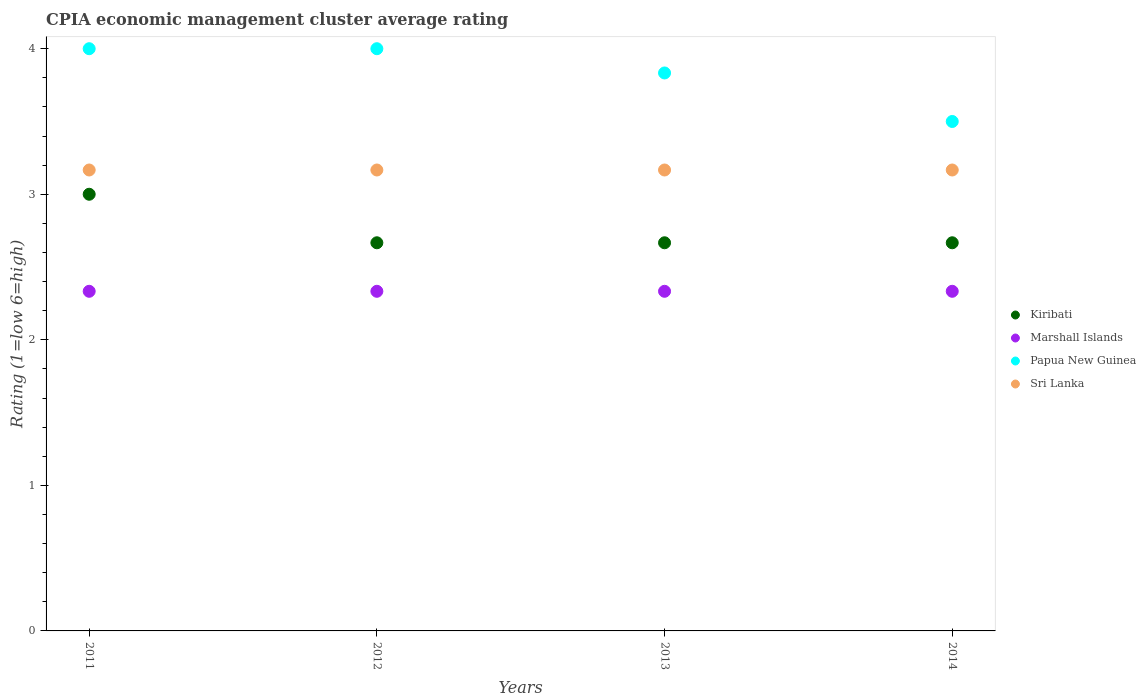Is the number of dotlines equal to the number of legend labels?
Provide a short and direct response. Yes. What is the CPIA rating in Marshall Islands in 2011?
Keep it short and to the point. 2.33. Across all years, what is the maximum CPIA rating in Marshall Islands?
Make the answer very short. 2.33. Across all years, what is the minimum CPIA rating in Kiribati?
Ensure brevity in your answer.  2.67. In which year was the CPIA rating in Papua New Guinea maximum?
Provide a succinct answer. 2011. What is the total CPIA rating in Marshall Islands in the graph?
Your response must be concise. 9.33. What is the difference between the CPIA rating in Kiribati in 2011 and that in 2014?
Ensure brevity in your answer.  0.33. What is the difference between the CPIA rating in Kiribati in 2011 and the CPIA rating in Marshall Islands in 2014?
Keep it short and to the point. 0.67. What is the average CPIA rating in Marshall Islands per year?
Ensure brevity in your answer.  2.33. In the year 2014, what is the difference between the CPIA rating in Papua New Guinea and CPIA rating in Marshall Islands?
Keep it short and to the point. 1.17. In how many years, is the CPIA rating in Sri Lanka greater than 1.8?
Your answer should be compact. 4. What is the ratio of the CPIA rating in Sri Lanka in 2011 to that in 2012?
Keep it short and to the point. 1. Is the CPIA rating in Sri Lanka in 2011 less than that in 2012?
Your answer should be compact. No. What is the difference between the highest and the second highest CPIA rating in Marshall Islands?
Your answer should be very brief. 0. What is the difference between the highest and the lowest CPIA rating in Kiribati?
Ensure brevity in your answer.  0.33. Is it the case that in every year, the sum of the CPIA rating in Sri Lanka and CPIA rating in Papua New Guinea  is greater than the sum of CPIA rating in Kiribati and CPIA rating in Marshall Islands?
Give a very brief answer. Yes. Does the CPIA rating in Sri Lanka monotonically increase over the years?
Ensure brevity in your answer.  No. How many years are there in the graph?
Your answer should be very brief. 4. What is the difference between two consecutive major ticks on the Y-axis?
Keep it short and to the point. 1. Does the graph contain grids?
Your answer should be compact. No. What is the title of the graph?
Provide a succinct answer. CPIA economic management cluster average rating. What is the label or title of the X-axis?
Your answer should be compact. Years. What is the label or title of the Y-axis?
Keep it short and to the point. Rating (1=low 6=high). What is the Rating (1=low 6=high) in Marshall Islands in 2011?
Keep it short and to the point. 2.33. What is the Rating (1=low 6=high) in Papua New Guinea in 2011?
Ensure brevity in your answer.  4. What is the Rating (1=low 6=high) of Sri Lanka in 2011?
Offer a terse response. 3.17. What is the Rating (1=low 6=high) in Kiribati in 2012?
Provide a short and direct response. 2.67. What is the Rating (1=low 6=high) in Marshall Islands in 2012?
Make the answer very short. 2.33. What is the Rating (1=low 6=high) of Sri Lanka in 2012?
Make the answer very short. 3.17. What is the Rating (1=low 6=high) in Kiribati in 2013?
Keep it short and to the point. 2.67. What is the Rating (1=low 6=high) in Marshall Islands in 2013?
Give a very brief answer. 2.33. What is the Rating (1=low 6=high) in Papua New Guinea in 2013?
Provide a succinct answer. 3.83. What is the Rating (1=low 6=high) of Sri Lanka in 2013?
Make the answer very short. 3.17. What is the Rating (1=low 6=high) of Kiribati in 2014?
Your response must be concise. 2.67. What is the Rating (1=low 6=high) in Marshall Islands in 2014?
Your answer should be compact. 2.33. What is the Rating (1=low 6=high) in Sri Lanka in 2014?
Make the answer very short. 3.17. Across all years, what is the maximum Rating (1=low 6=high) in Marshall Islands?
Your answer should be compact. 2.33. Across all years, what is the maximum Rating (1=low 6=high) of Papua New Guinea?
Make the answer very short. 4. Across all years, what is the maximum Rating (1=low 6=high) in Sri Lanka?
Offer a very short reply. 3.17. Across all years, what is the minimum Rating (1=low 6=high) of Kiribati?
Ensure brevity in your answer.  2.67. Across all years, what is the minimum Rating (1=low 6=high) of Marshall Islands?
Your answer should be compact. 2.33. Across all years, what is the minimum Rating (1=low 6=high) of Papua New Guinea?
Provide a short and direct response. 3.5. Across all years, what is the minimum Rating (1=low 6=high) in Sri Lanka?
Offer a very short reply. 3.17. What is the total Rating (1=low 6=high) of Kiribati in the graph?
Your answer should be compact. 11. What is the total Rating (1=low 6=high) of Marshall Islands in the graph?
Make the answer very short. 9.33. What is the total Rating (1=low 6=high) in Papua New Guinea in the graph?
Ensure brevity in your answer.  15.33. What is the total Rating (1=low 6=high) in Sri Lanka in the graph?
Make the answer very short. 12.67. What is the difference between the Rating (1=low 6=high) in Kiribati in 2011 and that in 2012?
Your response must be concise. 0.33. What is the difference between the Rating (1=low 6=high) of Marshall Islands in 2011 and that in 2012?
Offer a terse response. 0. What is the difference between the Rating (1=low 6=high) in Sri Lanka in 2011 and that in 2012?
Give a very brief answer. 0. What is the difference between the Rating (1=low 6=high) of Kiribati in 2011 and that in 2013?
Offer a very short reply. 0.33. What is the difference between the Rating (1=low 6=high) of Marshall Islands in 2011 and that in 2013?
Your answer should be compact. 0. What is the difference between the Rating (1=low 6=high) in Sri Lanka in 2011 and that in 2013?
Provide a short and direct response. 0. What is the difference between the Rating (1=low 6=high) of Papua New Guinea in 2011 and that in 2014?
Provide a short and direct response. 0.5. What is the difference between the Rating (1=low 6=high) of Kiribati in 2012 and that in 2013?
Provide a short and direct response. 0. What is the difference between the Rating (1=low 6=high) of Marshall Islands in 2012 and that in 2013?
Provide a succinct answer. 0. What is the difference between the Rating (1=low 6=high) of Kiribati in 2012 and that in 2014?
Give a very brief answer. -0. What is the difference between the Rating (1=low 6=high) of Papua New Guinea in 2012 and that in 2014?
Your response must be concise. 0.5. What is the difference between the Rating (1=low 6=high) in Papua New Guinea in 2013 and that in 2014?
Keep it short and to the point. 0.33. What is the difference between the Rating (1=low 6=high) in Kiribati in 2011 and the Rating (1=low 6=high) in Marshall Islands in 2012?
Provide a succinct answer. 0.67. What is the difference between the Rating (1=low 6=high) of Kiribati in 2011 and the Rating (1=low 6=high) of Papua New Guinea in 2012?
Offer a terse response. -1. What is the difference between the Rating (1=low 6=high) in Kiribati in 2011 and the Rating (1=low 6=high) in Sri Lanka in 2012?
Your answer should be very brief. -0.17. What is the difference between the Rating (1=low 6=high) in Marshall Islands in 2011 and the Rating (1=low 6=high) in Papua New Guinea in 2012?
Offer a very short reply. -1.67. What is the difference between the Rating (1=low 6=high) of Marshall Islands in 2011 and the Rating (1=low 6=high) of Sri Lanka in 2012?
Provide a succinct answer. -0.83. What is the difference between the Rating (1=low 6=high) in Papua New Guinea in 2011 and the Rating (1=low 6=high) in Sri Lanka in 2012?
Ensure brevity in your answer.  0.83. What is the difference between the Rating (1=low 6=high) of Kiribati in 2011 and the Rating (1=low 6=high) of Sri Lanka in 2013?
Give a very brief answer. -0.17. What is the difference between the Rating (1=low 6=high) of Marshall Islands in 2011 and the Rating (1=low 6=high) of Sri Lanka in 2013?
Make the answer very short. -0.83. What is the difference between the Rating (1=low 6=high) in Kiribati in 2011 and the Rating (1=low 6=high) in Marshall Islands in 2014?
Your answer should be compact. 0.67. What is the difference between the Rating (1=low 6=high) in Kiribati in 2011 and the Rating (1=low 6=high) in Papua New Guinea in 2014?
Provide a short and direct response. -0.5. What is the difference between the Rating (1=low 6=high) of Kiribati in 2011 and the Rating (1=low 6=high) of Sri Lanka in 2014?
Offer a very short reply. -0.17. What is the difference between the Rating (1=low 6=high) in Marshall Islands in 2011 and the Rating (1=low 6=high) in Papua New Guinea in 2014?
Ensure brevity in your answer.  -1.17. What is the difference between the Rating (1=low 6=high) of Kiribati in 2012 and the Rating (1=low 6=high) of Marshall Islands in 2013?
Your answer should be very brief. 0.33. What is the difference between the Rating (1=low 6=high) in Kiribati in 2012 and the Rating (1=low 6=high) in Papua New Guinea in 2013?
Your answer should be very brief. -1.17. What is the difference between the Rating (1=low 6=high) in Kiribati in 2012 and the Rating (1=low 6=high) in Sri Lanka in 2013?
Offer a terse response. -0.5. What is the difference between the Rating (1=low 6=high) of Marshall Islands in 2012 and the Rating (1=low 6=high) of Papua New Guinea in 2013?
Give a very brief answer. -1.5. What is the difference between the Rating (1=low 6=high) in Marshall Islands in 2012 and the Rating (1=low 6=high) in Sri Lanka in 2013?
Offer a terse response. -0.83. What is the difference between the Rating (1=low 6=high) of Kiribati in 2012 and the Rating (1=low 6=high) of Papua New Guinea in 2014?
Keep it short and to the point. -0.83. What is the difference between the Rating (1=low 6=high) of Kiribati in 2012 and the Rating (1=low 6=high) of Sri Lanka in 2014?
Offer a terse response. -0.5. What is the difference between the Rating (1=low 6=high) of Marshall Islands in 2012 and the Rating (1=low 6=high) of Papua New Guinea in 2014?
Your answer should be compact. -1.17. What is the difference between the Rating (1=low 6=high) of Marshall Islands in 2012 and the Rating (1=low 6=high) of Sri Lanka in 2014?
Keep it short and to the point. -0.83. What is the difference between the Rating (1=low 6=high) of Papua New Guinea in 2012 and the Rating (1=low 6=high) of Sri Lanka in 2014?
Ensure brevity in your answer.  0.83. What is the difference between the Rating (1=low 6=high) of Kiribati in 2013 and the Rating (1=low 6=high) of Papua New Guinea in 2014?
Provide a succinct answer. -0.83. What is the difference between the Rating (1=low 6=high) in Kiribati in 2013 and the Rating (1=low 6=high) in Sri Lanka in 2014?
Provide a short and direct response. -0.5. What is the difference between the Rating (1=low 6=high) in Marshall Islands in 2013 and the Rating (1=low 6=high) in Papua New Guinea in 2014?
Your answer should be compact. -1.17. What is the difference between the Rating (1=low 6=high) in Papua New Guinea in 2013 and the Rating (1=low 6=high) in Sri Lanka in 2014?
Provide a succinct answer. 0.67. What is the average Rating (1=low 6=high) in Kiribati per year?
Offer a terse response. 2.75. What is the average Rating (1=low 6=high) in Marshall Islands per year?
Make the answer very short. 2.33. What is the average Rating (1=low 6=high) in Papua New Guinea per year?
Make the answer very short. 3.83. What is the average Rating (1=low 6=high) of Sri Lanka per year?
Offer a terse response. 3.17. In the year 2011, what is the difference between the Rating (1=low 6=high) of Kiribati and Rating (1=low 6=high) of Marshall Islands?
Your answer should be compact. 0.67. In the year 2011, what is the difference between the Rating (1=low 6=high) of Kiribati and Rating (1=low 6=high) of Sri Lanka?
Your answer should be very brief. -0.17. In the year 2011, what is the difference between the Rating (1=low 6=high) of Marshall Islands and Rating (1=low 6=high) of Papua New Guinea?
Offer a very short reply. -1.67. In the year 2012, what is the difference between the Rating (1=low 6=high) in Kiribati and Rating (1=low 6=high) in Papua New Guinea?
Provide a short and direct response. -1.33. In the year 2012, what is the difference between the Rating (1=low 6=high) of Kiribati and Rating (1=low 6=high) of Sri Lanka?
Make the answer very short. -0.5. In the year 2012, what is the difference between the Rating (1=low 6=high) in Marshall Islands and Rating (1=low 6=high) in Papua New Guinea?
Your answer should be very brief. -1.67. In the year 2012, what is the difference between the Rating (1=low 6=high) of Marshall Islands and Rating (1=low 6=high) of Sri Lanka?
Provide a succinct answer. -0.83. In the year 2013, what is the difference between the Rating (1=low 6=high) of Kiribati and Rating (1=low 6=high) of Marshall Islands?
Make the answer very short. 0.33. In the year 2013, what is the difference between the Rating (1=low 6=high) of Kiribati and Rating (1=low 6=high) of Papua New Guinea?
Provide a succinct answer. -1.17. In the year 2013, what is the difference between the Rating (1=low 6=high) in Marshall Islands and Rating (1=low 6=high) in Papua New Guinea?
Your answer should be compact. -1.5. In the year 2013, what is the difference between the Rating (1=low 6=high) of Marshall Islands and Rating (1=low 6=high) of Sri Lanka?
Ensure brevity in your answer.  -0.83. In the year 2013, what is the difference between the Rating (1=low 6=high) in Papua New Guinea and Rating (1=low 6=high) in Sri Lanka?
Keep it short and to the point. 0.67. In the year 2014, what is the difference between the Rating (1=low 6=high) of Kiribati and Rating (1=low 6=high) of Marshall Islands?
Offer a very short reply. 0.33. In the year 2014, what is the difference between the Rating (1=low 6=high) of Kiribati and Rating (1=low 6=high) of Sri Lanka?
Your response must be concise. -0.5. In the year 2014, what is the difference between the Rating (1=low 6=high) of Marshall Islands and Rating (1=low 6=high) of Papua New Guinea?
Make the answer very short. -1.17. In the year 2014, what is the difference between the Rating (1=low 6=high) in Papua New Guinea and Rating (1=low 6=high) in Sri Lanka?
Offer a terse response. 0.33. What is the ratio of the Rating (1=low 6=high) in Marshall Islands in 2011 to that in 2012?
Ensure brevity in your answer.  1. What is the ratio of the Rating (1=low 6=high) of Kiribati in 2011 to that in 2013?
Make the answer very short. 1.12. What is the ratio of the Rating (1=low 6=high) in Marshall Islands in 2011 to that in 2013?
Your answer should be very brief. 1. What is the ratio of the Rating (1=low 6=high) in Papua New Guinea in 2011 to that in 2013?
Keep it short and to the point. 1.04. What is the ratio of the Rating (1=low 6=high) of Sri Lanka in 2011 to that in 2013?
Give a very brief answer. 1. What is the ratio of the Rating (1=low 6=high) of Marshall Islands in 2011 to that in 2014?
Offer a very short reply. 1. What is the ratio of the Rating (1=low 6=high) of Sri Lanka in 2011 to that in 2014?
Your response must be concise. 1. What is the ratio of the Rating (1=low 6=high) in Kiribati in 2012 to that in 2013?
Offer a very short reply. 1. What is the ratio of the Rating (1=low 6=high) in Marshall Islands in 2012 to that in 2013?
Provide a short and direct response. 1. What is the ratio of the Rating (1=low 6=high) of Papua New Guinea in 2012 to that in 2013?
Make the answer very short. 1.04. What is the ratio of the Rating (1=low 6=high) of Sri Lanka in 2012 to that in 2013?
Your answer should be very brief. 1. What is the ratio of the Rating (1=low 6=high) of Kiribati in 2012 to that in 2014?
Provide a short and direct response. 1. What is the ratio of the Rating (1=low 6=high) of Marshall Islands in 2012 to that in 2014?
Make the answer very short. 1. What is the ratio of the Rating (1=low 6=high) of Papua New Guinea in 2012 to that in 2014?
Your response must be concise. 1.14. What is the ratio of the Rating (1=low 6=high) in Sri Lanka in 2012 to that in 2014?
Make the answer very short. 1. What is the ratio of the Rating (1=low 6=high) in Papua New Guinea in 2013 to that in 2014?
Your answer should be compact. 1.1. What is the ratio of the Rating (1=low 6=high) in Sri Lanka in 2013 to that in 2014?
Offer a very short reply. 1. What is the difference between the highest and the second highest Rating (1=low 6=high) of Papua New Guinea?
Ensure brevity in your answer.  0. What is the difference between the highest and the second highest Rating (1=low 6=high) in Sri Lanka?
Offer a terse response. 0. What is the difference between the highest and the lowest Rating (1=low 6=high) in Kiribati?
Offer a very short reply. 0.33. What is the difference between the highest and the lowest Rating (1=low 6=high) of Marshall Islands?
Keep it short and to the point. 0. 